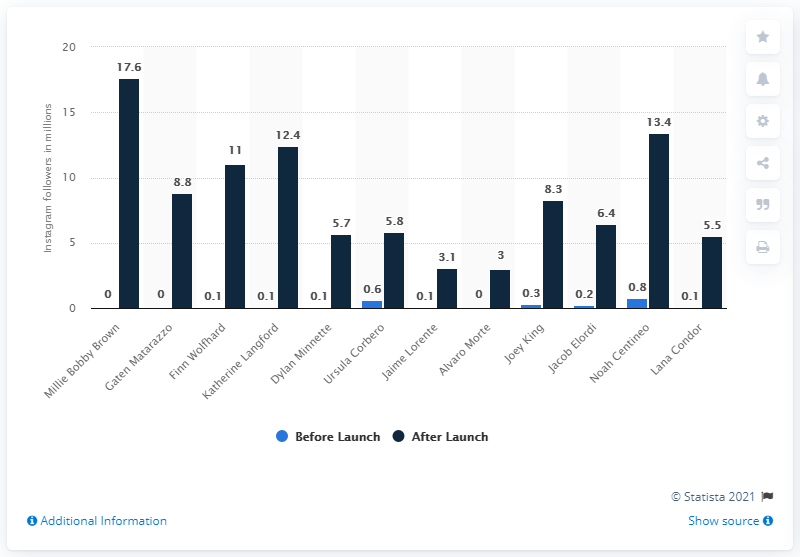Specify some key components in this picture. Millie Bobby Brown had 17.6 followers after her debut on Stranger Things. 